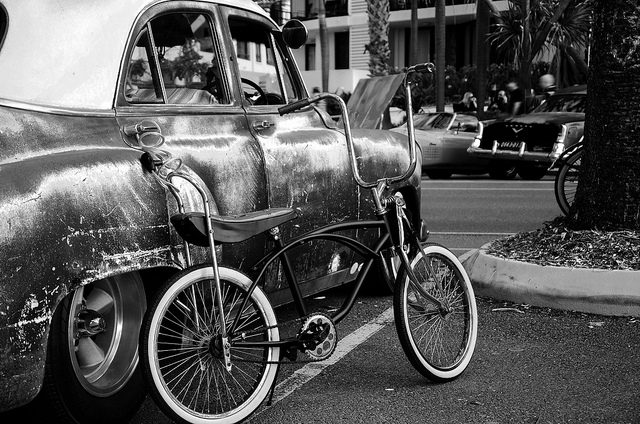How many bicycles are in the photo? 2 